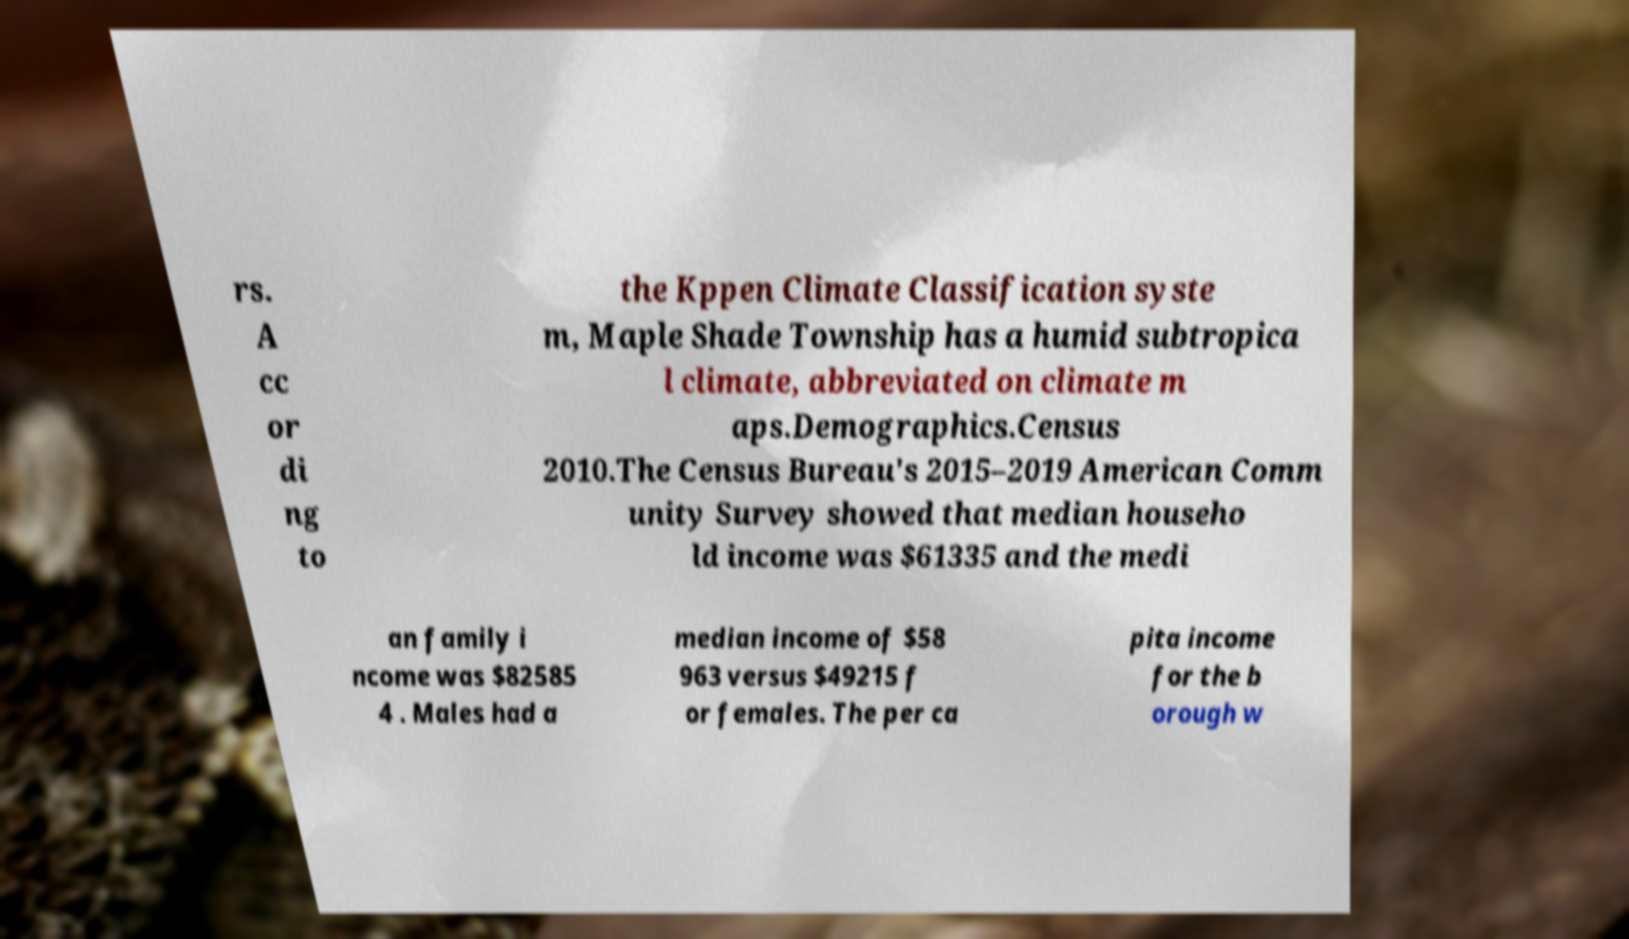What messages or text are displayed in this image? I need them in a readable, typed format. rs. A cc or di ng to the Kppen Climate Classification syste m, Maple Shade Township has a humid subtropica l climate, abbreviated on climate m aps.Demographics.Census 2010.The Census Bureau's 2015–2019 American Comm unity Survey showed that median househo ld income was $61335 and the medi an family i ncome was $82585 4 . Males had a median income of $58 963 versus $49215 f or females. The per ca pita income for the b orough w 